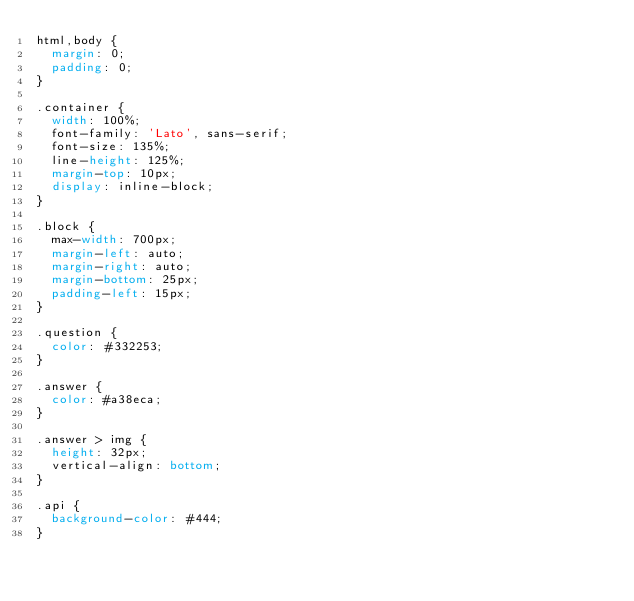Convert code to text. <code><loc_0><loc_0><loc_500><loc_500><_CSS_>html,body {
  margin: 0;
  padding: 0;
}

.container {
  width: 100%;
  font-family: 'Lato', sans-serif;
  font-size: 135%;
  line-height: 125%;
  margin-top: 10px;
  display: inline-block;
}

.block {
  max-width: 700px;
  margin-left: auto;
  margin-right: auto;
  margin-bottom: 25px;
  padding-left: 15px;
}

.question {
  color: #332253;
}

.answer {
  color: #a38eca;
}

.answer > img {
  height: 32px;
  vertical-align: bottom;
}

.api {
  background-color: #444;
}
</code> 